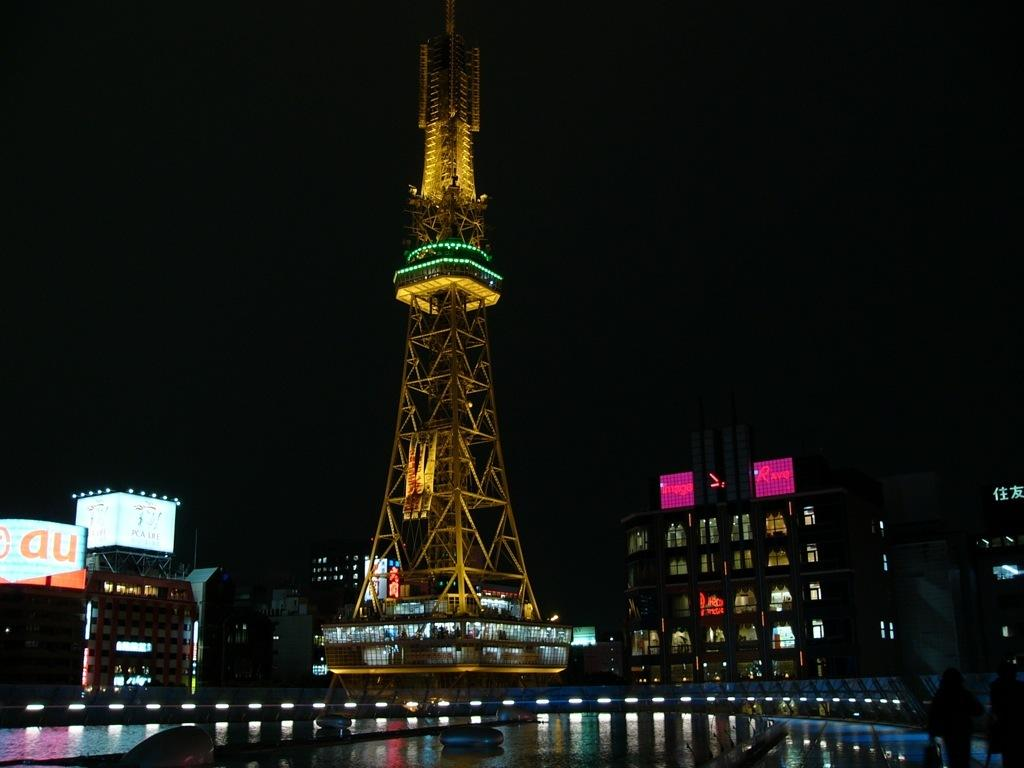What is the main structure in the image? There is a yellow iron tower in the image. Are there any other structures near the tower? A: Yes, there are buildings beside the tower. What can be seen at the front bottom side of the image? There are spotlights and a water pond in the front bottom side of the image. How many brothers are playing on the hill in the image? There is no hill or brothers present in the image. 